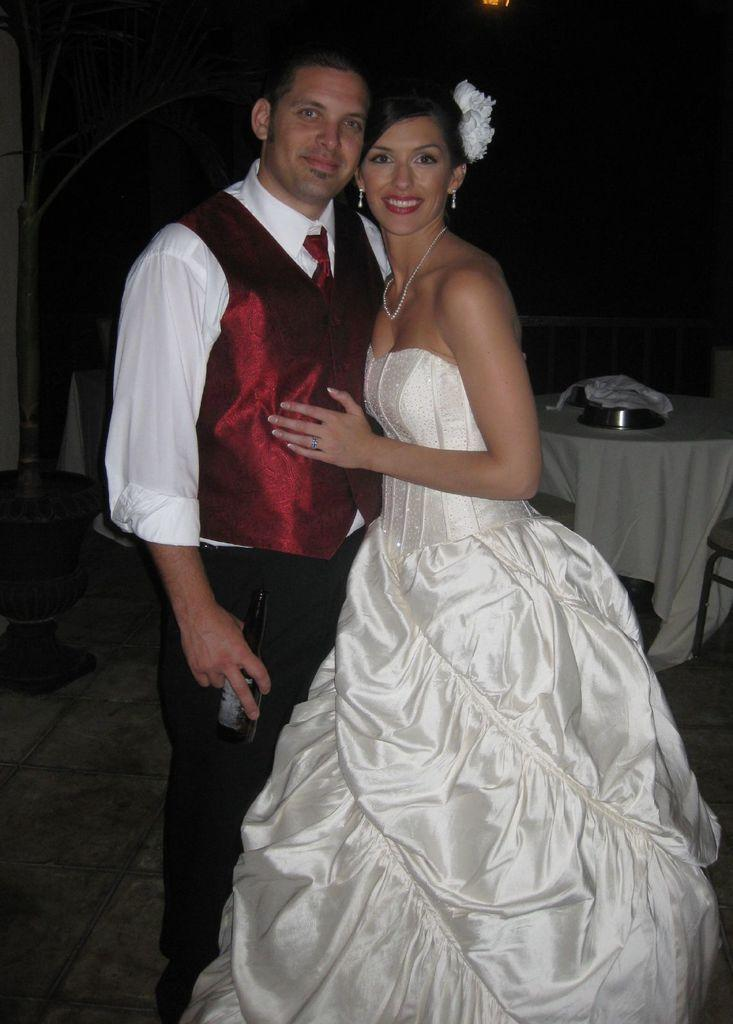Who is present in the image? There is a man and a woman in the image. What is the woman wearing? The woman is wearing a white dress. What are the man and woman doing in the image? They are standing and laughing. What can be seen in the background of the image? There is a table in the background of the image. How would you describe the lighting in the image? The background of the image is dark. What type of machine is being used by the woman in the image? There is no machine present in the image; the woman is simply wearing a white dress and laughing with the man. 